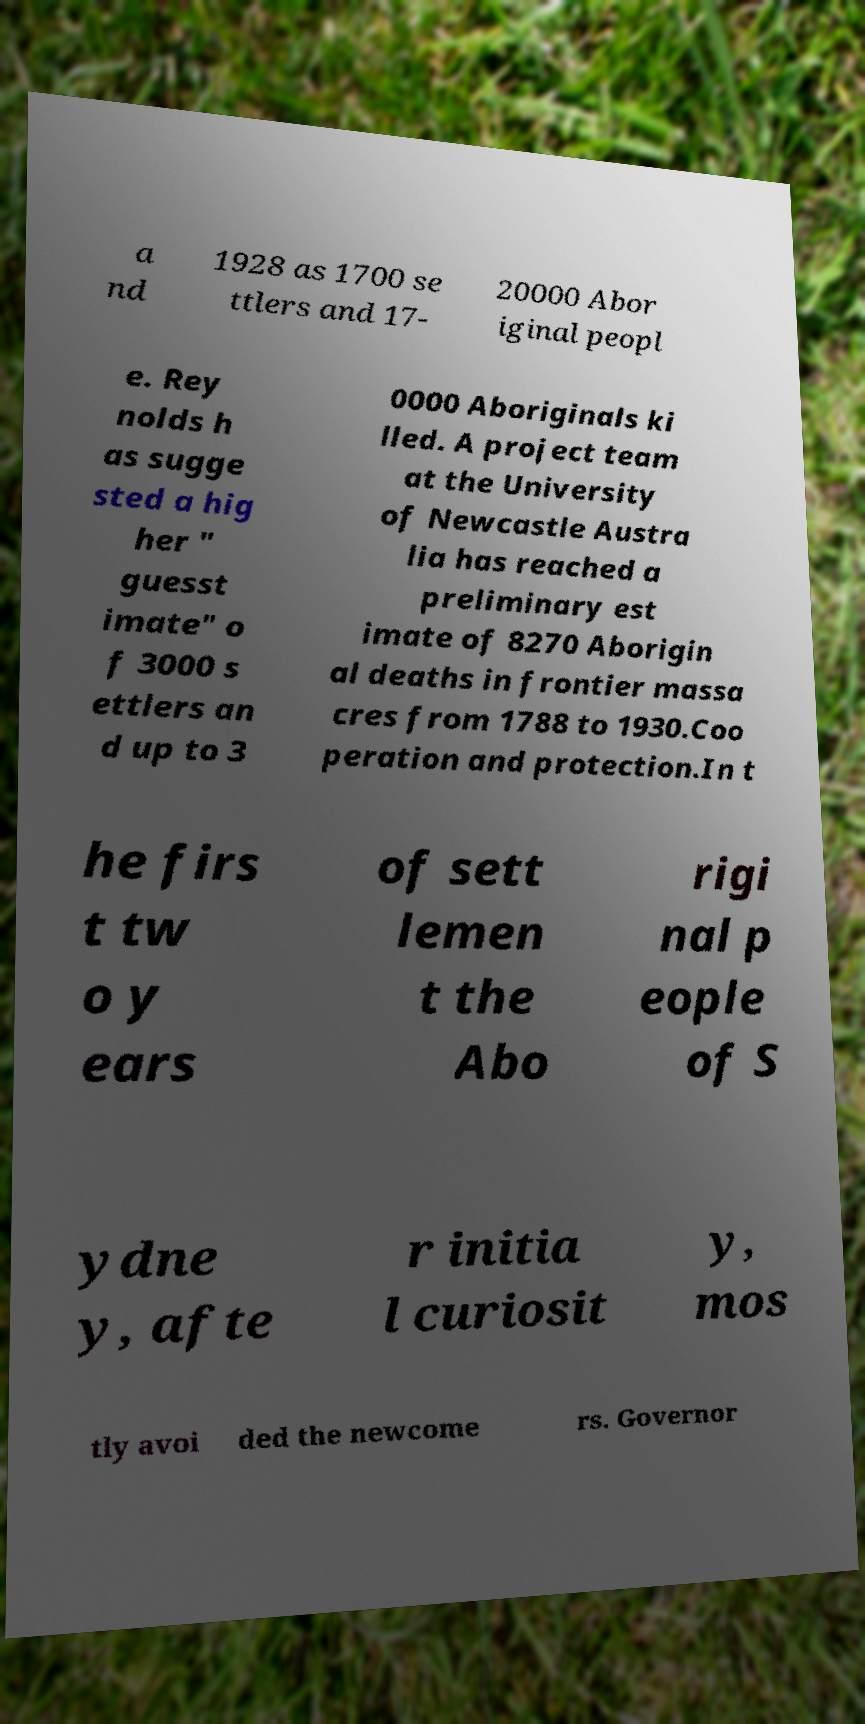Could you extract and type out the text from this image? a nd 1928 as 1700 se ttlers and 17- 20000 Abor iginal peopl e. Rey nolds h as sugge sted a hig her " guesst imate" o f 3000 s ettlers an d up to 3 0000 Aboriginals ki lled. A project team at the University of Newcastle Austra lia has reached a preliminary est imate of 8270 Aborigin al deaths in frontier massa cres from 1788 to 1930.Coo peration and protection.In t he firs t tw o y ears of sett lemen t the Abo rigi nal p eople of S ydne y, afte r initia l curiosit y, mos tly avoi ded the newcome rs. Governor 